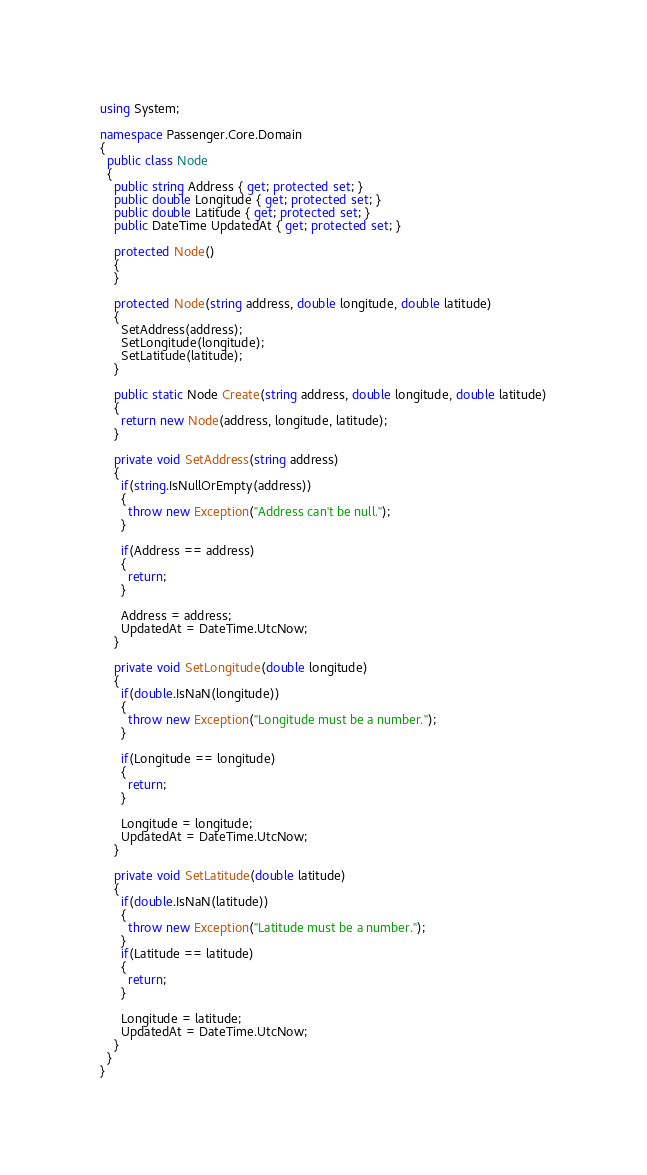<code> <loc_0><loc_0><loc_500><loc_500><_C#_>using System;

namespace Passenger.Core.Domain
{
  public class Node
  {
    public string Address { get; protected set; }
    public double Longitude { get; protected set; }
    public double Latitude { get; protected set; }
    public DateTime UpdatedAt { get; protected set; }

    protected Node()
    {
    }

    protected Node(string address, double longitude, double latitude)
    {
      SetAddress(address);
      SetLongitude(longitude);
      SetLatitude(latitude);
    }

    public static Node Create(string address, double longitude, double latitude)
    {
      return new Node(address, longitude, latitude);
    }

    private void SetAddress(string address)
    {
      if(string.IsNullOrEmpty(address))
      {
        throw new Exception("Address can't be null.");
      }

      if(Address == address)
      {
        return;
      }

      Address = address;
      UpdatedAt = DateTime.UtcNow;
    }

    private void SetLongitude(double longitude)
    {
      if(double.IsNaN(longitude))
      {
        throw new Exception("Longitude must be a number.");
      }

      if(Longitude == longitude)
      {
        return;
      }

      Longitude = longitude;
      UpdatedAt = DateTime.UtcNow;
    }

    private void SetLatitude(double latitude)
    {
      if(double.IsNaN(latitude))
      {
        throw new Exception("Latitude must be a number.");
      }
      if(Latitude == latitude)
      {
        return;
      }

      Longitude = latitude;
      UpdatedAt = DateTime.UtcNow;
    }
  }
}</code> 